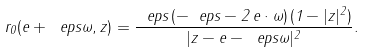Convert formula to latex. <formula><loc_0><loc_0><loc_500><loc_500>r _ { 0 } ( e + \ e p s \omega , z ) = \frac { \ e p s \, ( - \ e p s - 2 \, e \cdot \omega ) \, ( 1 - | z | ^ { 2 } ) } { | z - e - \ e p s \omega | ^ { 2 } } .</formula> 